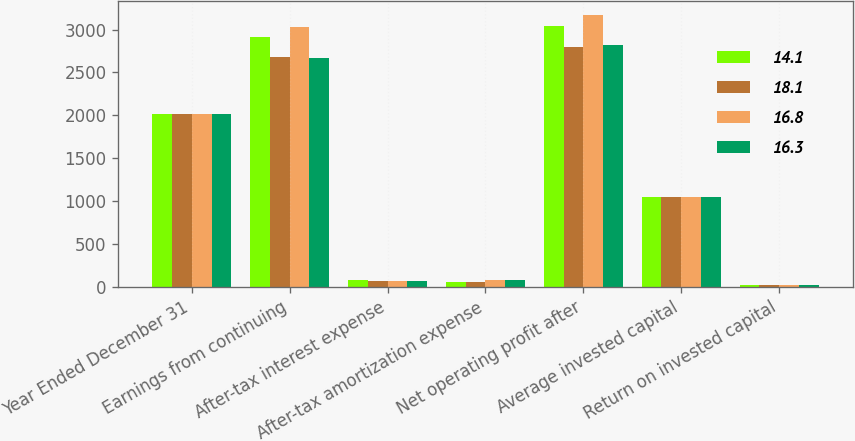<chart> <loc_0><loc_0><loc_500><loc_500><stacked_bar_chart><ecel><fcel>Year Ended December 31<fcel>Earnings from continuing<fcel>After-tax interest expense<fcel>After-tax amortization expense<fcel>Net operating profit after<fcel>Average invested capital<fcel>Return on invested capital<nl><fcel>14.1<fcel>2017<fcel>2912<fcel>76<fcel>51<fcel>3039<fcel>1046.5<fcel>16.8<nl><fcel>18.1<fcel>2016<fcel>2679<fcel>64<fcel>57<fcel>2800<fcel>1046.5<fcel>16.3<nl><fcel>16.8<fcel>2015<fcel>3036<fcel>64<fcel>75<fcel>3175<fcel>1046.5<fcel>18.1<nl><fcel>16.3<fcel>2014<fcel>2673<fcel>67<fcel>79<fcel>2819<fcel>1046.5<fcel>15.1<nl></chart> 